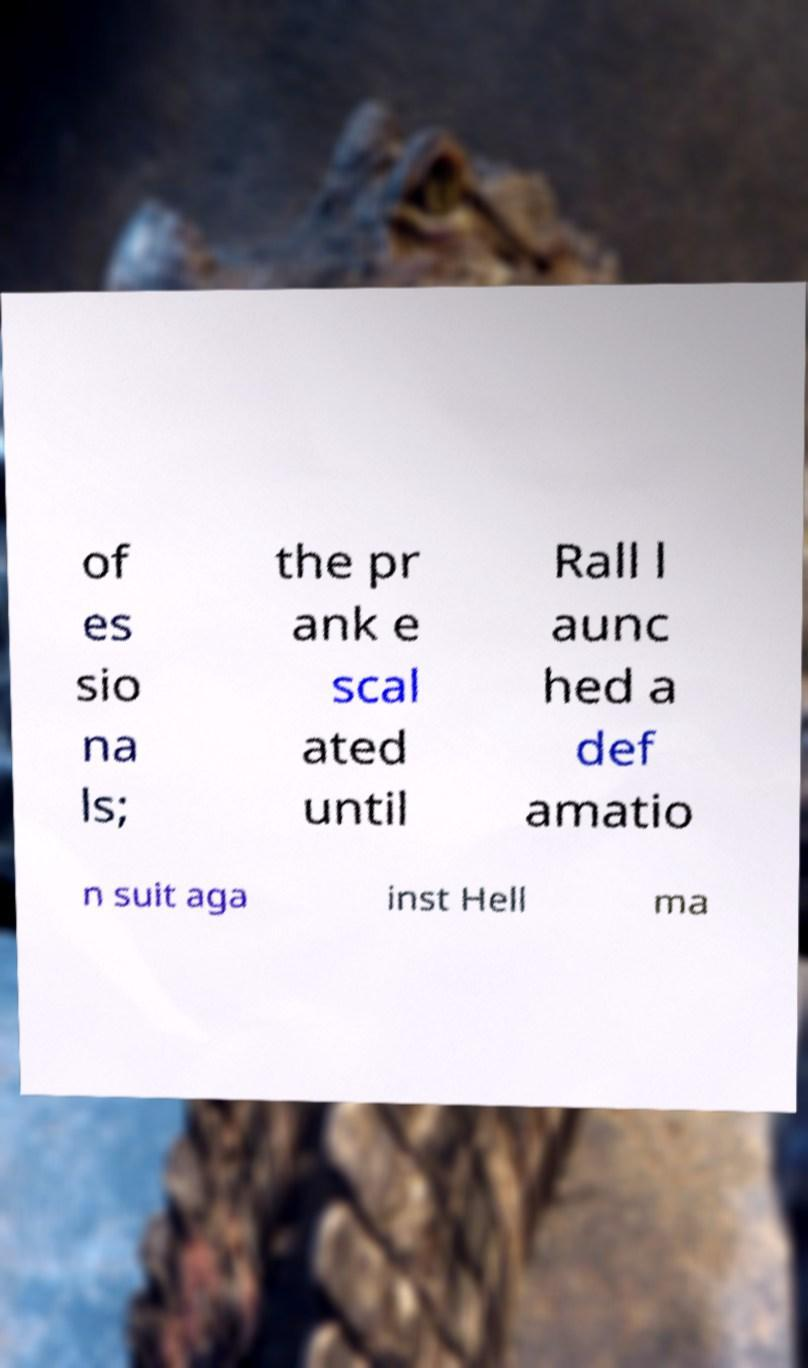Could you extract and type out the text from this image? of es sio na ls; the pr ank e scal ated until Rall l aunc hed a def amatio n suit aga inst Hell ma 